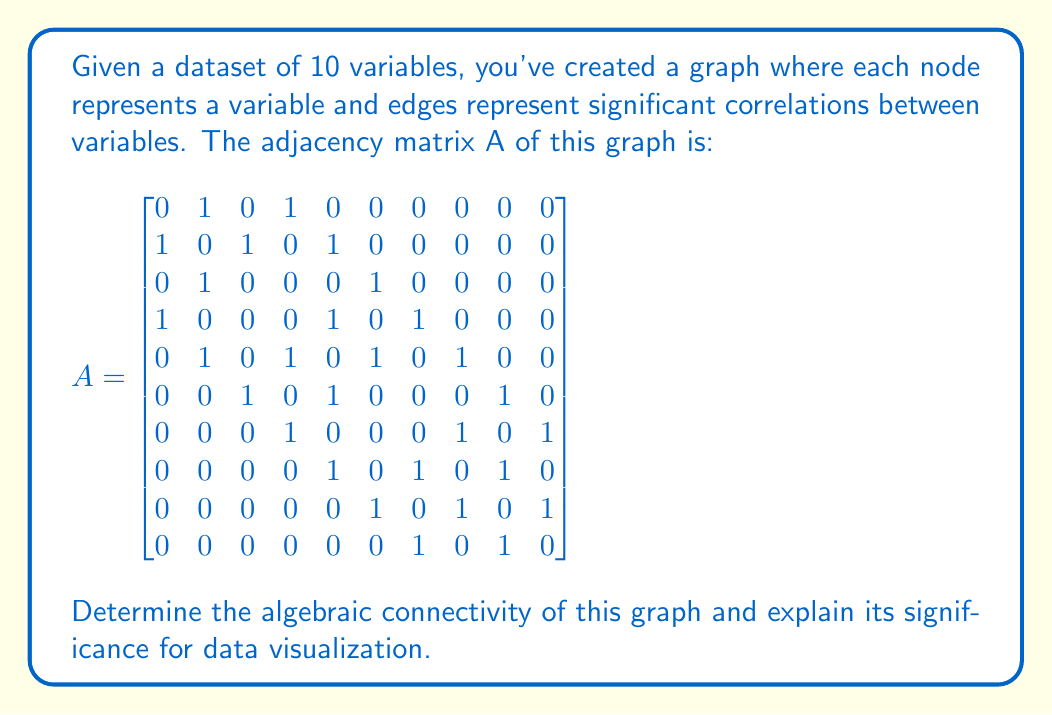What is the answer to this math problem? To solve this problem, we need to follow these steps:

1) The algebraic connectivity of a graph is defined as the second smallest eigenvalue of the Laplacian matrix of the graph.

2) First, we need to calculate the Laplacian matrix L. The Laplacian matrix is defined as L = D - A, where D is the degree matrix and A is the adjacency matrix.

3) The degree matrix D is a diagonal matrix where each entry $d_{ii}$ is the degree of vertex i. We can calculate this from the adjacency matrix:

$$
D = \begin{bmatrix}
2 & 0 & 0 & 0 & 0 & 0 & 0 & 0 & 0 & 0 \\
0 & 3 & 0 & 0 & 0 & 0 & 0 & 0 & 0 & 0 \\
0 & 0 & 2 & 0 & 0 & 0 & 0 & 0 & 0 & 0 \\
0 & 0 & 0 & 3 & 0 & 0 & 0 & 0 & 0 & 0 \\
0 & 0 & 0 & 0 & 4 & 0 & 0 & 0 & 0 & 0 \\
0 & 0 & 0 & 0 & 0 & 3 & 0 & 0 & 0 & 0 \\
0 & 0 & 0 & 0 & 0 & 0 & 3 & 0 & 0 & 0 \\
0 & 0 & 0 & 0 & 0 & 0 & 0 & 3 & 0 & 0 \\
0 & 0 & 0 & 0 & 0 & 0 & 0 & 0 & 3 & 0 \\
0 & 0 & 0 & 0 & 0 & 0 & 0 & 0 & 0 & 2
\end{bmatrix}
$$

4) Now we can calculate L = D - A:

$$
L = \begin{bmatrix}
2 & -1 & 0 & -1 & 0 & 0 & 0 & 0 & 0 & 0 \\
-1 & 3 & -1 & 0 & -1 & 0 & 0 & 0 & 0 & 0 \\
0 & -1 & 2 & 0 & 0 & -1 & 0 & 0 & 0 & 0 \\
-1 & 0 & 0 & 3 & -1 & 0 & -1 & 0 & 0 & 0 \\
0 & -1 & 0 & -1 & 4 & -1 & 0 & -1 & 0 & 0 \\
0 & 0 & -1 & 0 & -1 & 3 & 0 & 0 & -1 & 0 \\
0 & 0 & 0 & -1 & 0 & 0 & 3 & -1 & 0 & -1 \\
0 & 0 & 0 & 0 & -1 & 0 & -1 & 3 & -1 & 0 \\
0 & 0 & 0 & 0 & 0 & -1 & 0 & -1 & 3 & -1 \\
0 & 0 & 0 & 0 & 0 & 0 & -1 & 0 & -1 & 2
\end{bmatrix}
$$

5) The eigenvalues of L can be calculated using numerical methods. The second smallest eigenvalue (rounded to 4 decimal places) is 0.3249.

6) Therefore, the algebraic connectivity of the graph is 0.3249.

The significance of algebraic connectivity for data visualization:

a) It measures how well-connected the graph is as a whole. A higher value indicates a more connected graph.

b) It's related to the graph's robustness to disconnection. Graphs with higher algebraic connectivity are harder to disconnect by removing edges.

c) In the context of data visualization, it can help in understanding the overall structure of relationships between variables. A higher value suggests that the variables are more interconnected, which might influence how you choose to visualize the data.

d) It can be used as a measure of how well the graph can be partitioned, which is useful for clustering algorithms often used in data visualization techniques.

e) The eigenvector associated with this eigenvalue (the Fiedler vector) can be used for spectral clustering and dimensionality reduction, which are important techniques in data visualization.
Answer: The algebraic connectivity of the graph is 0.3249 (rounded to 4 decimal places). 